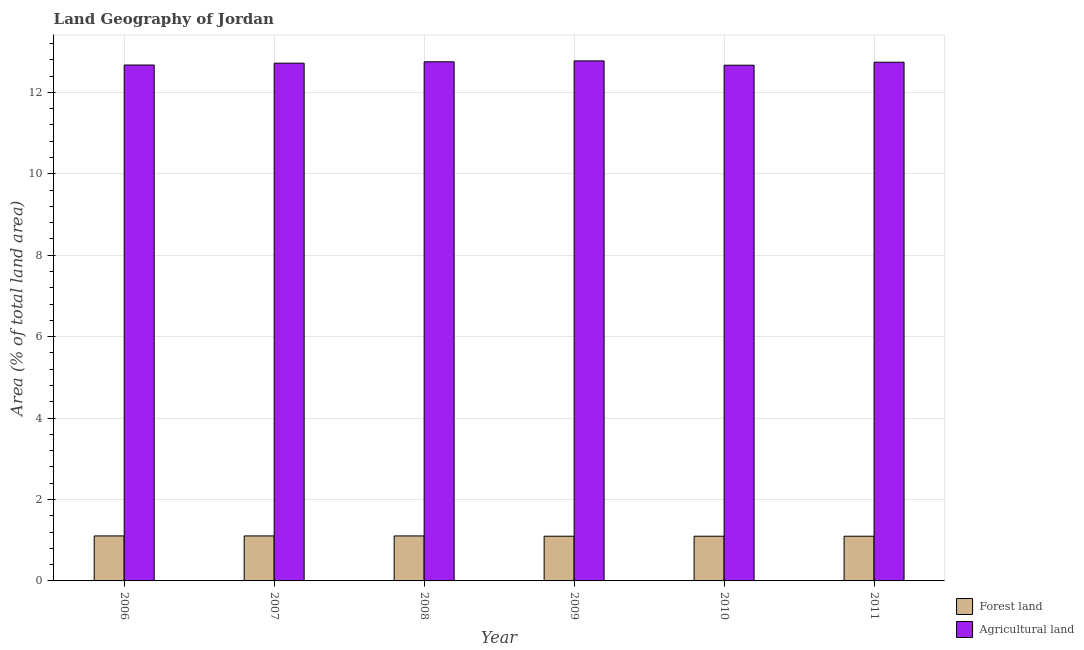How many different coloured bars are there?
Your answer should be compact. 2. How many bars are there on the 5th tick from the right?
Provide a short and direct response. 2. What is the label of the 3rd group of bars from the left?
Offer a very short reply. 2008. In how many cases, is the number of bars for a given year not equal to the number of legend labels?
Keep it short and to the point. 0. What is the percentage of land area under forests in 2010?
Your response must be concise. 1.1. Across all years, what is the maximum percentage of land area under agriculture?
Keep it short and to the point. 12.77. Across all years, what is the minimum percentage of land area under forests?
Provide a short and direct response. 1.1. In which year was the percentage of land area under forests maximum?
Your answer should be very brief. 2006. What is the total percentage of land area under forests in the graph?
Your answer should be very brief. 6.61. What is the difference between the percentage of land area under agriculture in 2008 and that in 2009?
Offer a very short reply. -0.02. What is the difference between the percentage of land area under forests in 2010 and the percentage of land area under agriculture in 2006?
Your answer should be very brief. -0.01. What is the average percentage of land area under agriculture per year?
Offer a very short reply. 12.72. In the year 2007, what is the difference between the percentage of land area under forests and percentage of land area under agriculture?
Offer a very short reply. 0. What is the ratio of the percentage of land area under agriculture in 2009 to that in 2010?
Make the answer very short. 1.01. Is the percentage of land area under agriculture in 2008 less than that in 2009?
Your answer should be compact. Yes. What is the difference between the highest and the second highest percentage of land area under agriculture?
Your response must be concise. 0.02. What is the difference between the highest and the lowest percentage of land area under forests?
Your answer should be compact. 0.01. In how many years, is the percentage of land area under forests greater than the average percentage of land area under forests taken over all years?
Keep it short and to the point. 3. Is the sum of the percentage of land area under forests in 2006 and 2007 greater than the maximum percentage of land area under agriculture across all years?
Provide a succinct answer. Yes. What does the 1st bar from the left in 2008 represents?
Ensure brevity in your answer.  Forest land. What does the 2nd bar from the right in 2011 represents?
Your answer should be compact. Forest land. How many bars are there?
Give a very brief answer. 12. What is the difference between two consecutive major ticks on the Y-axis?
Make the answer very short. 2. Are the values on the major ticks of Y-axis written in scientific E-notation?
Your answer should be compact. No. Does the graph contain any zero values?
Provide a short and direct response. No. What is the title of the graph?
Provide a short and direct response. Land Geography of Jordan. What is the label or title of the Y-axis?
Your answer should be compact. Area (% of total land area). What is the Area (% of total land area) of Forest land in 2006?
Your response must be concise. 1.1. What is the Area (% of total land area) in Agricultural land in 2006?
Give a very brief answer. 12.67. What is the Area (% of total land area) of Forest land in 2007?
Offer a terse response. 1.1. What is the Area (% of total land area) in Agricultural land in 2007?
Offer a terse response. 12.72. What is the Area (% of total land area) of Forest land in 2008?
Offer a terse response. 1.1. What is the Area (% of total land area) of Agricultural land in 2008?
Offer a terse response. 12.75. What is the Area (% of total land area) in Forest land in 2009?
Your response must be concise. 1.1. What is the Area (% of total land area) of Agricultural land in 2009?
Keep it short and to the point. 12.77. What is the Area (% of total land area) in Forest land in 2010?
Ensure brevity in your answer.  1.1. What is the Area (% of total land area) in Agricultural land in 2010?
Your answer should be compact. 12.67. What is the Area (% of total land area) of Forest land in 2011?
Provide a short and direct response. 1.1. What is the Area (% of total land area) of Agricultural land in 2011?
Offer a terse response. 12.74. Across all years, what is the maximum Area (% of total land area) of Forest land?
Your response must be concise. 1.1. Across all years, what is the maximum Area (% of total land area) in Agricultural land?
Provide a succinct answer. 12.77. Across all years, what is the minimum Area (% of total land area) of Forest land?
Make the answer very short. 1.1. Across all years, what is the minimum Area (% of total land area) in Agricultural land?
Ensure brevity in your answer.  12.67. What is the total Area (% of total land area) in Forest land in the graph?
Offer a terse response. 6.61. What is the total Area (% of total land area) of Agricultural land in the graph?
Offer a very short reply. 76.31. What is the difference between the Area (% of total land area) in Forest land in 2006 and that in 2007?
Give a very brief answer. 0. What is the difference between the Area (% of total land area) in Agricultural land in 2006 and that in 2007?
Offer a very short reply. -0.05. What is the difference between the Area (% of total land area) of Forest land in 2006 and that in 2008?
Provide a succinct answer. 0. What is the difference between the Area (% of total land area) in Agricultural land in 2006 and that in 2008?
Make the answer very short. -0.08. What is the difference between the Area (% of total land area) in Forest land in 2006 and that in 2009?
Your response must be concise. 0.01. What is the difference between the Area (% of total land area) of Agricultural land in 2006 and that in 2009?
Make the answer very short. -0.1. What is the difference between the Area (% of total land area) in Forest land in 2006 and that in 2010?
Offer a very short reply. 0.01. What is the difference between the Area (% of total land area) of Agricultural land in 2006 and that in 2010?
Your response must be concise. 0. What is the difference between the Area (% of total land area) in Forest land in 2006 and that in 2011?
Your response must be concise. 0.01. What is the difference between the Area (% of total land area) of Agricultural land in 2006 and that in 2011?
Your answer should be compact. -0.07. What is the difference between the Area (% of total land area) of Agricultural land in 2007 and that in 2008?
Your answer should be very brief. -0.03. What is the difference between the Area (% of total land area) in Forest land in 2007 and that in 2009?
Give a very brief answer. 0.01. What is the difference between the Area (% of total land area) of Agricultural land in 2007 and that in 2009?
Provide a succinct answer. -0.06. What is the difference between the Area (% of total land area) in Forest land in 2007 and that in 2010?
Ensure brevity in your answer.  0.01. What is the difference between the Area (% of total land area) of Agricultural land in 2007 and that in 2010?
Your response must be concise. 0.05. What is the difference between the Area (% of total land area) of Forest land in 2007 and that in 2011?
Your answer should be compact. 0.01. What is the difference between the Area (% of total land area) in Agricultural land in 2007 and that in 2011?
Make the answer very short. -0.02. What is the difference between the Area (% of total land area) of Forest land in 2008 and that in 2009?
Your answer should be very brief. 0.01. What is the difference between the Area (% of total land area) in Agricultural land in 2008 and that in 2009?
Your answer should be very brief. -0.02. What is the difference between the Area (% of total land area) of Forest land in 2008 and that in 2010?
Your answer should be compact. 0.01. What is the difference between the Area (% of total land area) in Agricultural land in 2008 and that in 2010?
Your answer should be very brief. 0.08. What is the difference between the Area (% of total land area) of Forest land in 2008 and that in 2011?
Your response must be concise. 0.01. What is the difference between the Area (% of total land area) of Agricultural land in 2008 and that in 2011?
Offer a terse response. 0.01. What is the difference between the Area (% of total land area) of Agricultural land in 2009 and that in 2010?
Your answer should be very brief. 0.11. What is the difference between the Area (% of total land area) in Agricultural land in 2009 and that in 2011?
Offer a terse response. 0.03. What is the difference between the Area (% of total land area) in Agricultural land in 2010 and that in 2011?
Keep it short and to the point. -0.07. What is the difference between the Area (% of total land area) of Forest land in 2006 and the Area (% of total land area) of Agricultural land in 2007?
Make the answer very short. -11.61. What is the difference between the Area (% of total land area) of Forest land in 2006 and the Area (% of total land area) of Agricultural land in 2008?
Offer a terse response. -11.64. What is the difference between the Area (% of total land area) of Forest land in 2006 and the Area (% of total land area) of Agricultural land in 2009?
Give a very brief answer. -11.67. What is the difference between the Area (% of total land area) of Forest land in 2006 and the Area (% of total land area) of Agricultural land in 2010?
Give a very brief answer. -11.56. What is the difference between the Area (% of total land area) in Forest land in 2006 and the Area (% of total land area) in Agricultural land in 2011?
Your response must be concise. -11.63. What is the difference between the Area (% of total land area) of Forest land in 2007 and the Area (% of total land area) of Agricultural land in 2008?
Keep it short and to the point. -11.64. What is the difference between the Area (% of total land area) of Forest land in 2007 and the Area (% of total land area) of Agricultural land in 2009?
Keep it short and to the point. -11.67. What is the difference between the Area (% of total land area) of Forest land in 2007 and the Area (% of total land area) of Agricultural land in 2010?
Your answer should be very brief. -11.56. What is the difference between the Area (% of total land area) in Forest land in 2007 and the Area (% of total land area) in Agricultural land in 2011?
Give a very brief answer. -11.63. What is the difference between the Area (% of total land area) of Forest land in 2008 and the Area (% of total land area) of Agricultural land in 2009?
Offer a very short reply. -11.67. What is the difference between the Area (% of total land area) in Forest land in 2008 and the Area (% of total land area) in Agricultural land in 2010?
Offer a very short reply. -11.56. What is the difference between the Area (% of total land area) of Forest land in 2008 and the Area (% of total land area) of Agricultural land in 2011?
Your response must be concise. -11.63. What is the difference between the Area (% of total land area) in Forest land in 2009 and the Area (% of total land area) in Agricultural land in 2010?
Make the answer very short. -11.57. What is the difference between the Area (% of total land area) in Forest land in 2009 and the Area (% of total land area) in Agricultural land in 2011?
Provide a short and direct response. -11.64. What is the difference between the Area (% of total land area) in Forest land in 2010 and the Area (% of total land area) in Agricultural land in 2011?
Give a very brief answer. -11.64. What is the average Area (% of total land area) of Forest land per year?
Offer a very short reply. 1.1. What is the average Area (% of total land area) in Agricultural land per year?
Provide a succinct answer. 12.72. In the year 2006, what is the difference between the Area (% of total land area) of Forest land and Area (% of total land area) of Agricultural land?
Your response must be concise. -11.56. In the year 2007, what is the difference between the Area (% of total land area) of Forest land and Area (% of total land area) of Agricultural land?
Your answer should be very brief. -11.61. In the year 2008, what is the difference between the Area (% of total land area) in Forest land and Area (% of total land area) in Agricultural land?
Give a very brief answer. -11.64. In the year 2009, what is the difference between the Area (% of total land area) of Forest land and Area (% of total land area) of Agricultural land?
Offer a terse response. -11.67. In the year 2010, what is the difference between the Area (% of total land area) of Forest land and Area (% of total land area) of Agricultural land?
Your answer should be compact. -11.57. In the year 2011, what is the difference between the Area (% of total land area) in Forest land and Area (% of total land area) in Agricultural land?
Give a very brief answer. -11.64. What is the ratio of the Area (% of total land area) of Forest land in 2006 to that in 2008?
Your answer should be compact. 1. What is the ratio of the Area (% of total land area) in Agricultural land in 2006 to that in 2008?
Your response must be concise. 0.99. What is the ratio of the Area (% of total land area) of Agricultural land in 2006 to that in 2009?
Your answer should be compact. 0.99. What is the ratio of the Area (% of total land area) of Forest land in 2006 to that in 2010?
Keep it short and to the point. 1.01. What is the ratio of the Area (% of total land area) of Agricultural land in 2006 to that in 2011?
Your answer should be compact. 0.99. What is the ratio of the Area (% of total land area) of Agricultural land in 2007 to that in 2009?
Make the answer very short. 1. What is the ratio of the Area (% of total land area) in Forest land in 2007 to that in 2010?
Ensure brevity in your answer.  1.01. What is the ratio of the Area (% of total land area) in Agricultural land in 2007 to that in 2010?
Ensure brevity in your answer.  1. What is the ratio of the Area (% of total land area) in Forest land in 2007 to that in 2011?
Your answer should be very brief. 1.01. What is the ratio of the Area (% of total land area) in Agricultural land in 2007 to that in 2011?
Your answer should be compact. 1. What is the ratio of the Area (% of total land area) in Forest land in 2008 to that in 2009?
Ensure brevity in your answer.  1.01. What is the ratio of the Area (% of total land area) of Agricultural land in 2008 to that in 2009?
Your answer should be compact. 1. What is the ratio of the Area (% of total land area) of Forest land in 2008 to that in 2010?
Your answer should be compact. 1.01. What is the ratio of the Area (% of total land area) in Agricultural land in 2008 to that in 2010?
Provide a short and direct response. 1.01. What is the ratio of the Area (% of total land area) of Agricultural land in 2009 to that in 2010?
Provide a short and direct response. 1.01. What is the ratio of the Area (% of total land area) of Forest land in 2009 to that in 2011?
Your answer should be compact. 1. What is the difference between the highest and the second highest Area (% of total land area) of Agricultural land?
Your answer should be compact. 0.02. What is the difference between the highest and the lowest Area (% of total land area) of Forest land?
Offer a terse response. 0.01. What is the difference between the highest and the lowest Area (% of total land area) of Agricultural land?
Keep it short and to the point. 0.11. 